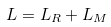Convert formula to latex. <formula><loc_0><loc_0><loc_500><loc_500>L = L _ { R } + L _ { M }</formula> 